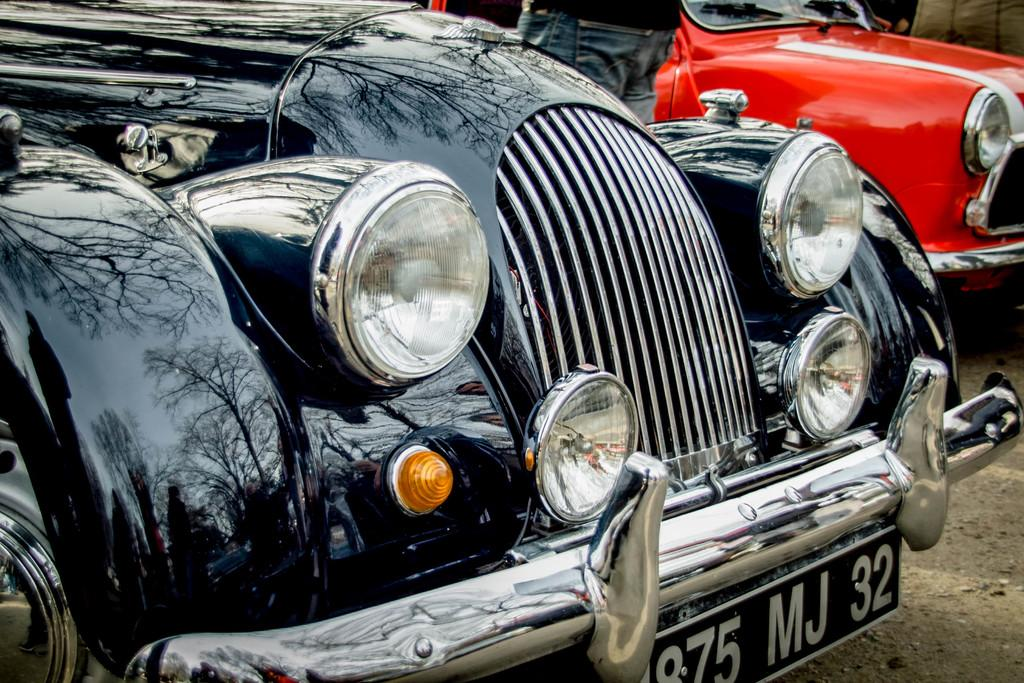How many cars are visible in the image? There are two cars in the image. Can you describe the person in the image? There is a person standing beside the second car. What type of bikes are being shown in the image? There are no bikes present in the image. 